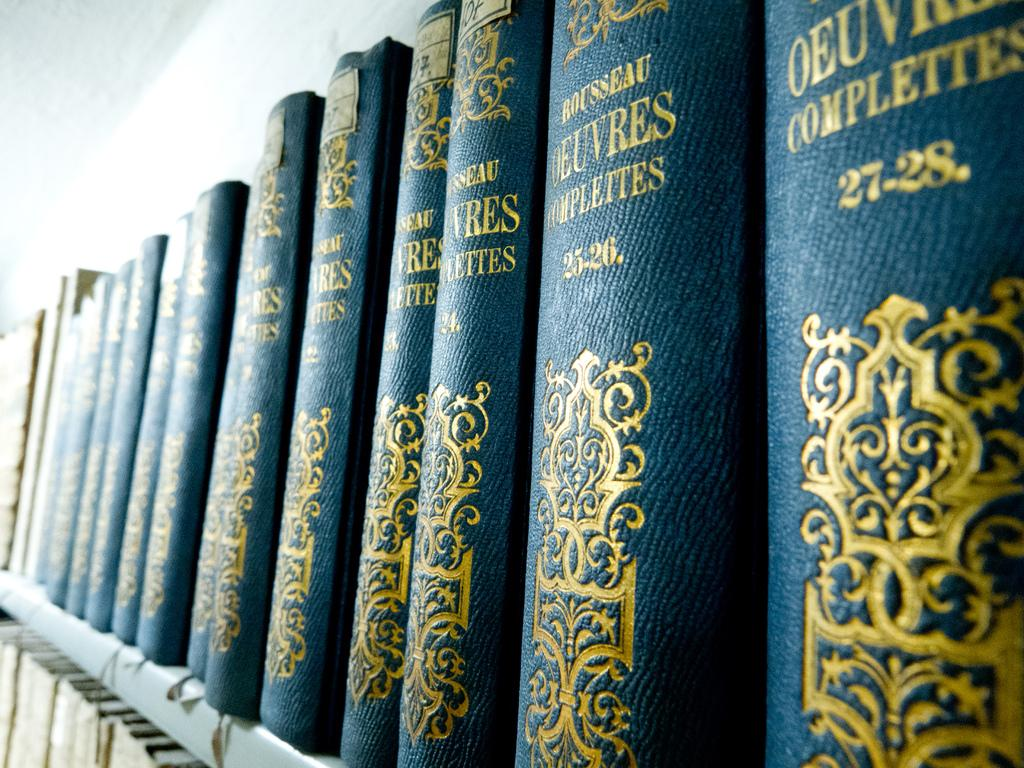<image>
Write a terse but informative summary of the picture. Many volumes of Rousseau Oeuvres Complettes are on a shelf 